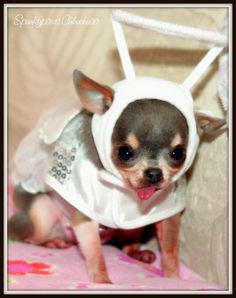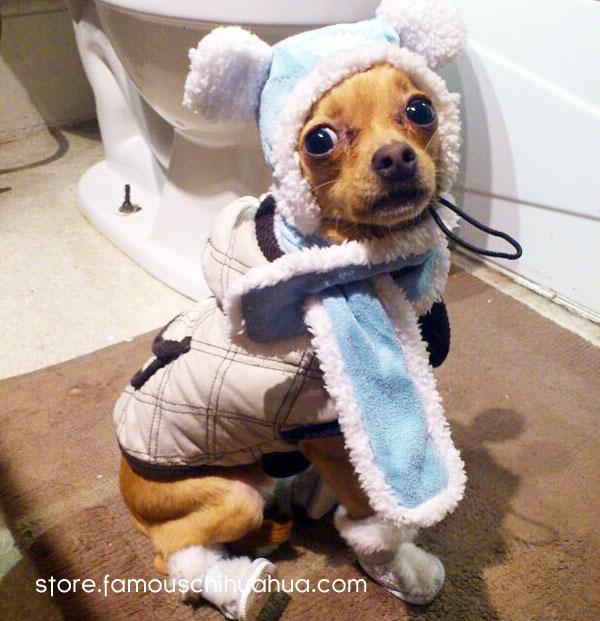The first image is the image on the left, the second image is the image on the right. Given the left and right images, does the statement "At least one of the dogs is wearing a hat on it's head." hold true? Answer yes or no. Yes. The first image is the image on the left, the second image is the image on the right. Examine the images to the left and right. Is the description "A dog wears a hat in at least one image." accurate? Answer yes or no. Yes. 